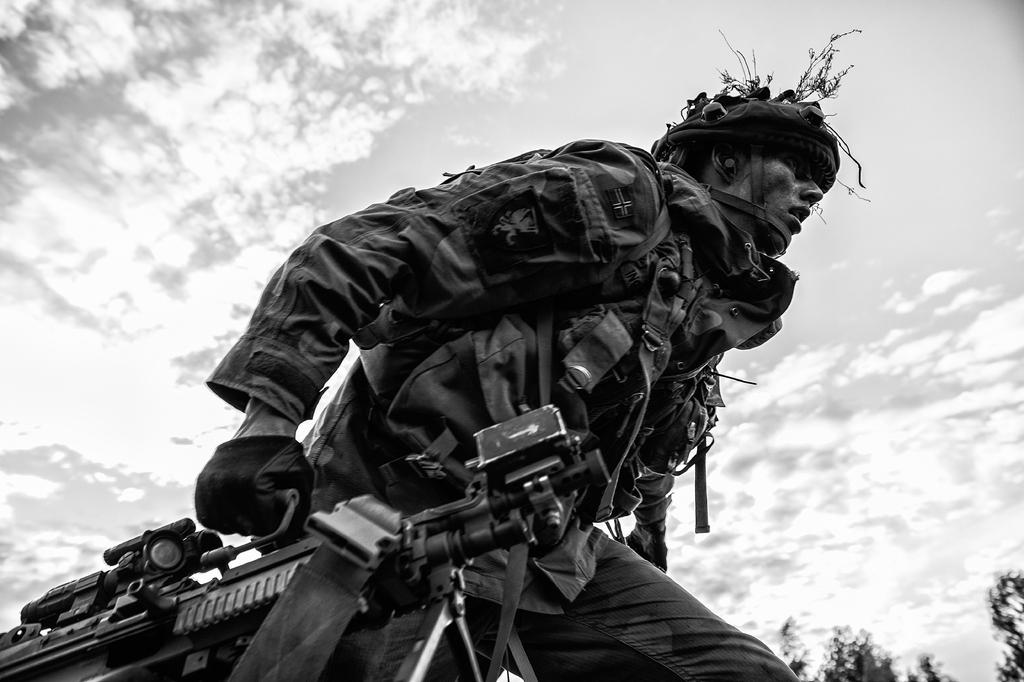What is the color scheme of the image? The image is black and white. Who is present in the image? There is a man in the image. What is the man wearing? The man is wearing a uniform. What is the man holding in the image? The man is holding weapons. What can be seen in the background of the image? There is sky visible in the background of the image, with clouds and trees present. What type of water can be seen in the image? There is no water visible in the image. Is the man in the image a lawyer? The image does not provide any information about the man's profession, so we cannot determine if he is a lawyer or not. 